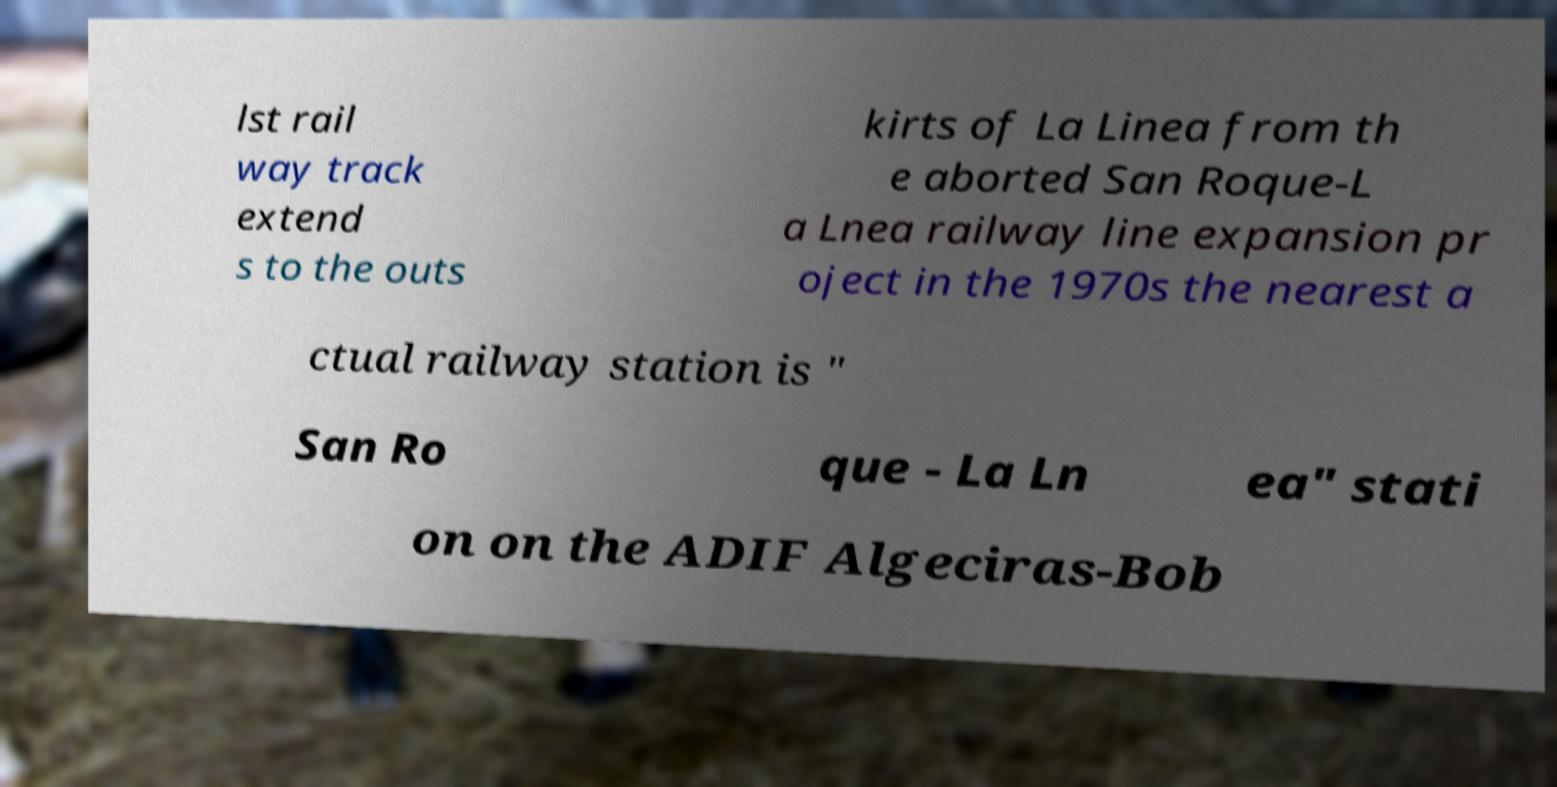Could you assist in decoding the text presented in this image and type it out clearly? lst rail way track extend s to the outs kirts of La Linea from th e aborted San Roque-L a Lnea railway line expansion pr oject in the 1970s the nearest a ctual railway station is " San Ro que - La Ln ea" stati on on the ADIF Algeciras-Bob 